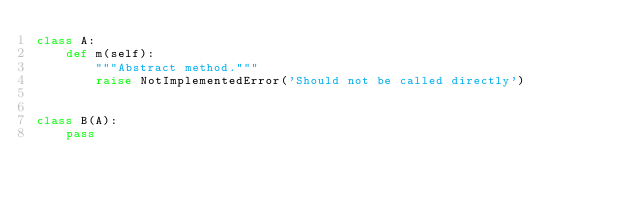<code> <loc_0><loc_0><loc_500><loc_500><_Python_>class A:
    def m(self):
        """Abstract method."""
        raise NotImplementedError('Should not be called directly')


class B(A):
    pass
</code> 